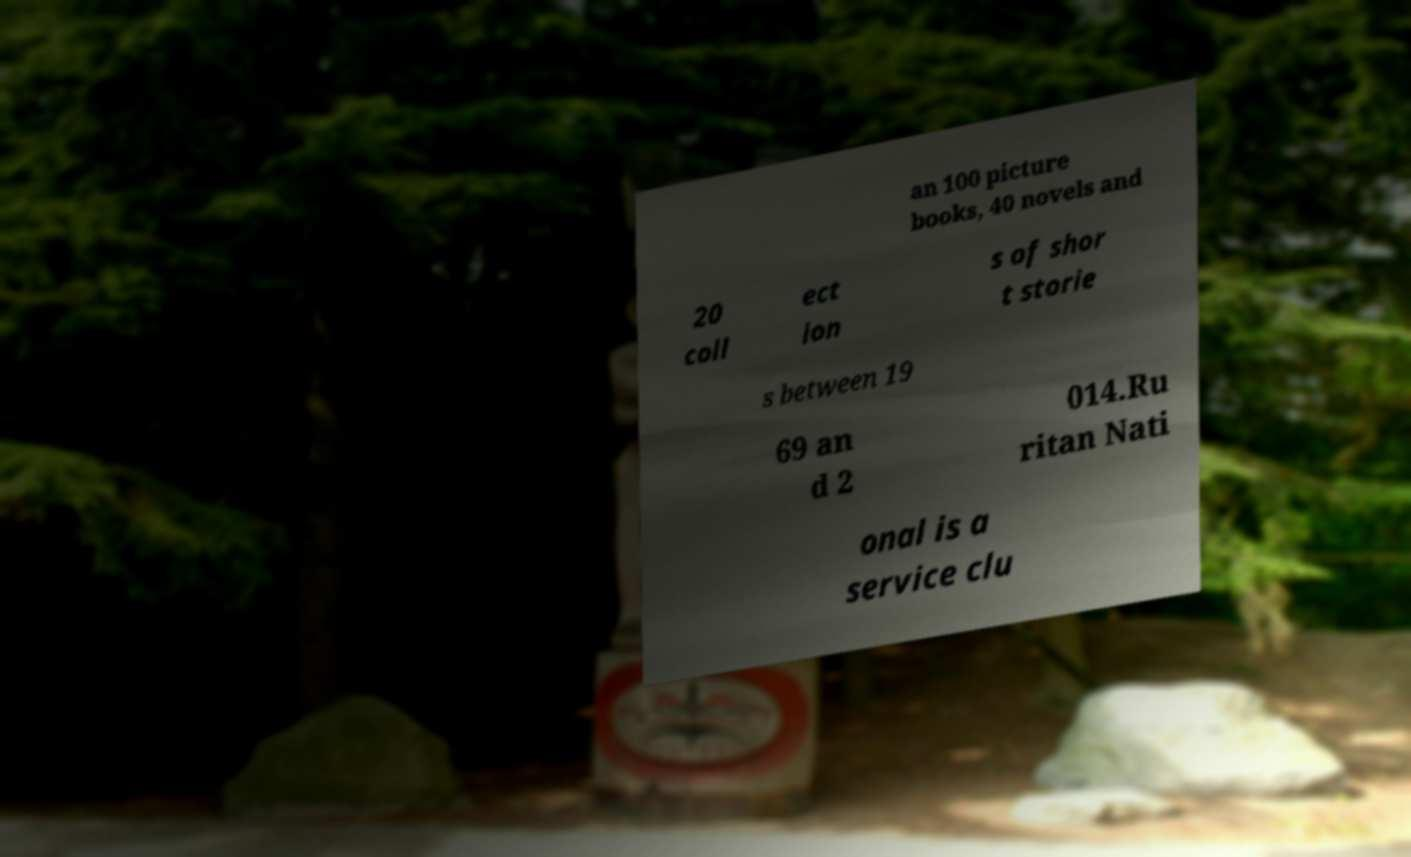Could you extract and type out the text from this image? an 100 picture books, 40 novels and 20 coll ect ion s of shor t storie s between 19 69 an d 2 014.Ru ritan Nati onal is a service clu 